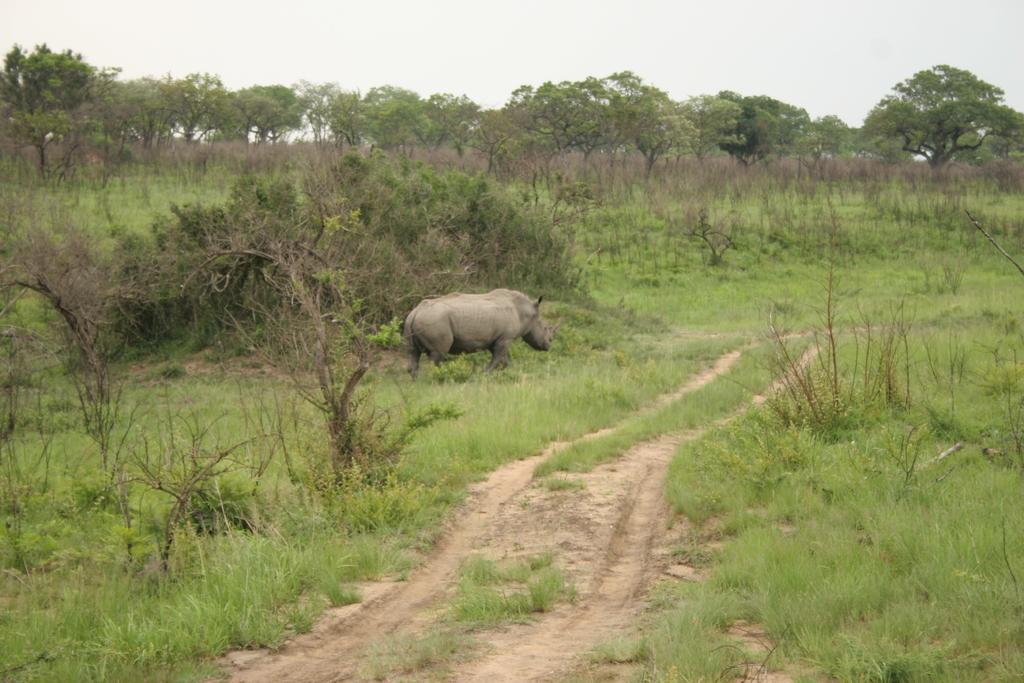Can you describe this image briefly? In this picture we can see a rhino, in the background we can find grass and few trees. 